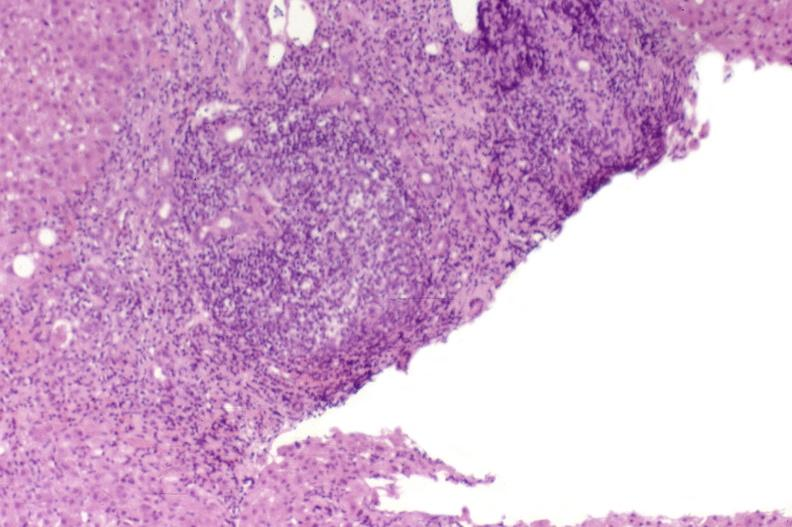s monoclonal gammopathy present?
Answer the question using a single word or phrase. No 